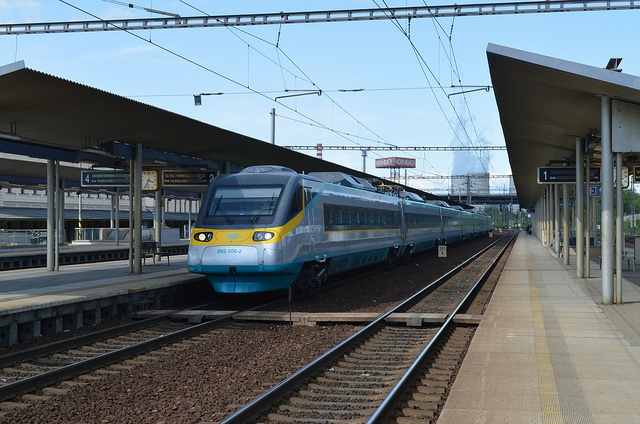Describe the objects in this image and their specific colors. I can see train in lavender, black, blue, gray, and navy tones, clock in lavender, darkgray, gray, and olive tones, and clock in lavender, darkgray, gray, black, and olive tones in this image. 